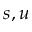<formula> <loc_0><loc_0><loc_500><loc_500>s , u</formula> 